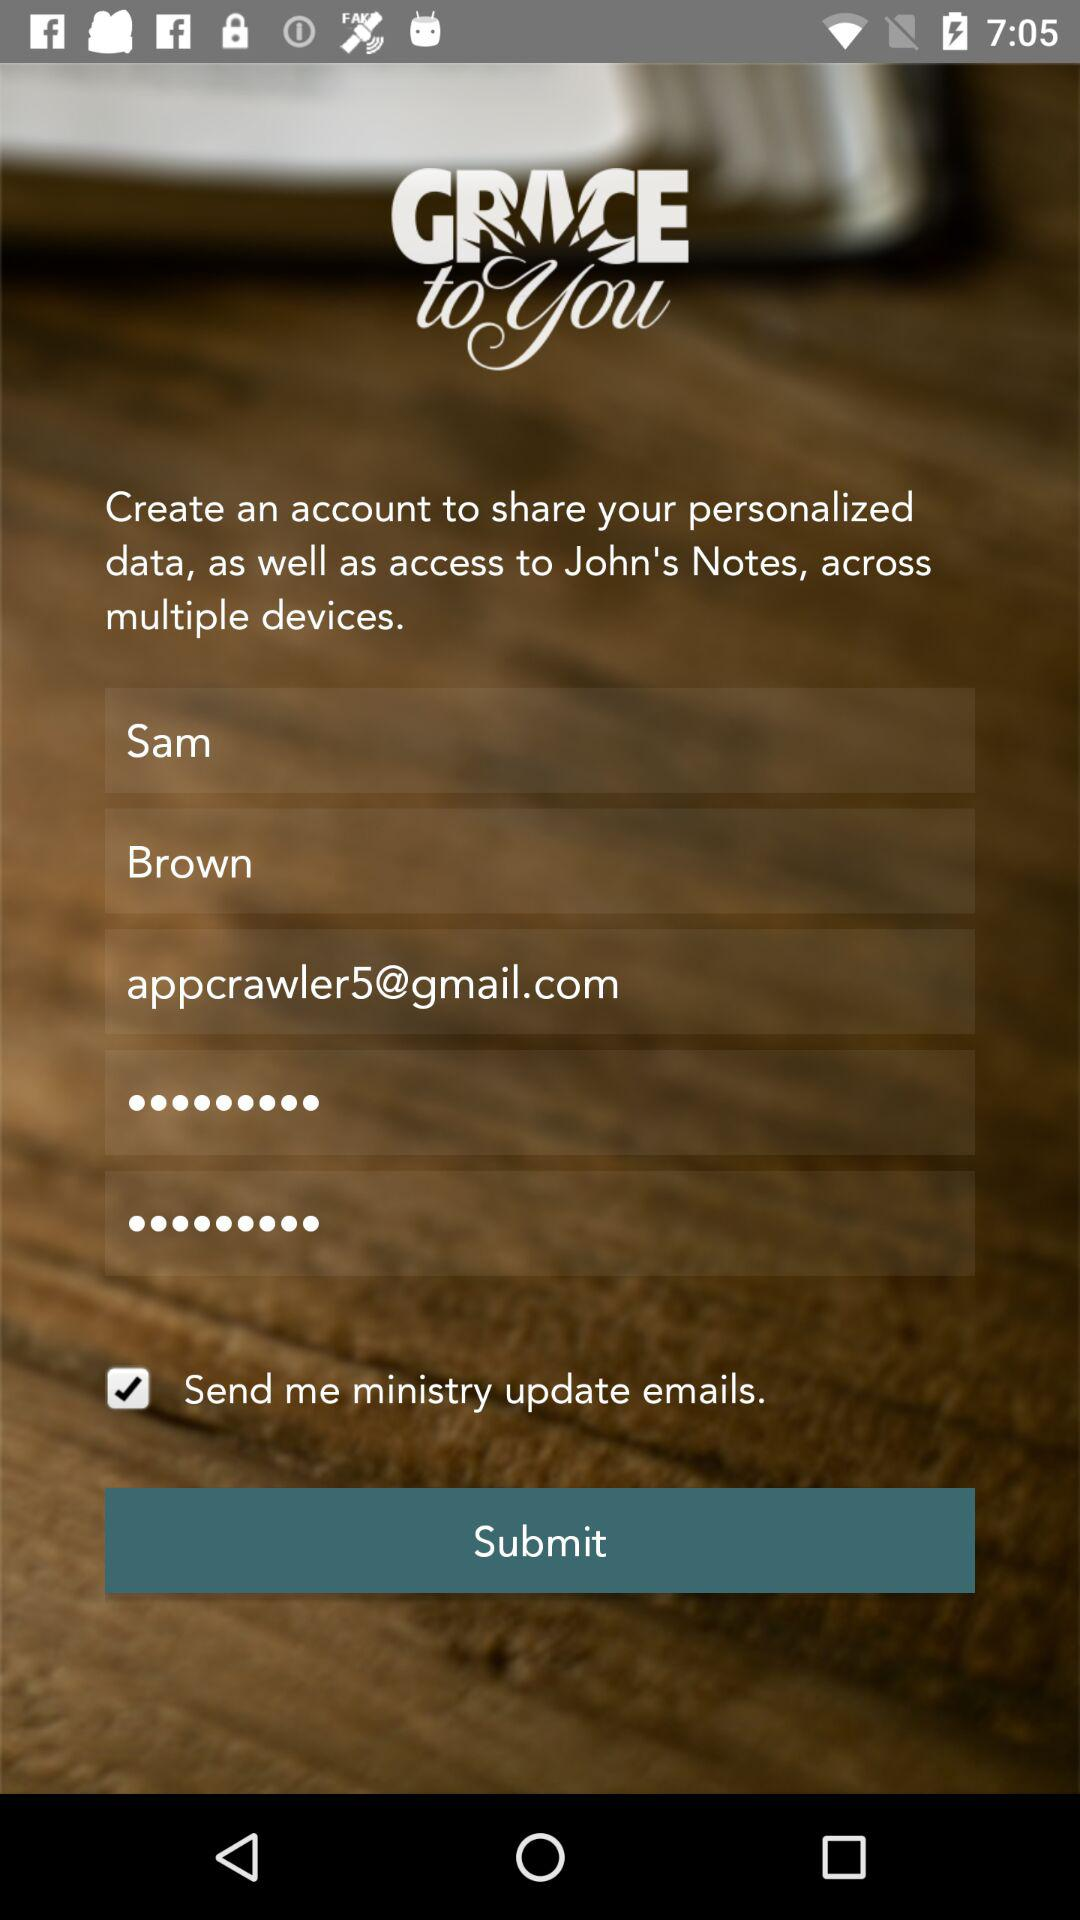What is the email address? The email address is appcrawler5@gmail.com. 